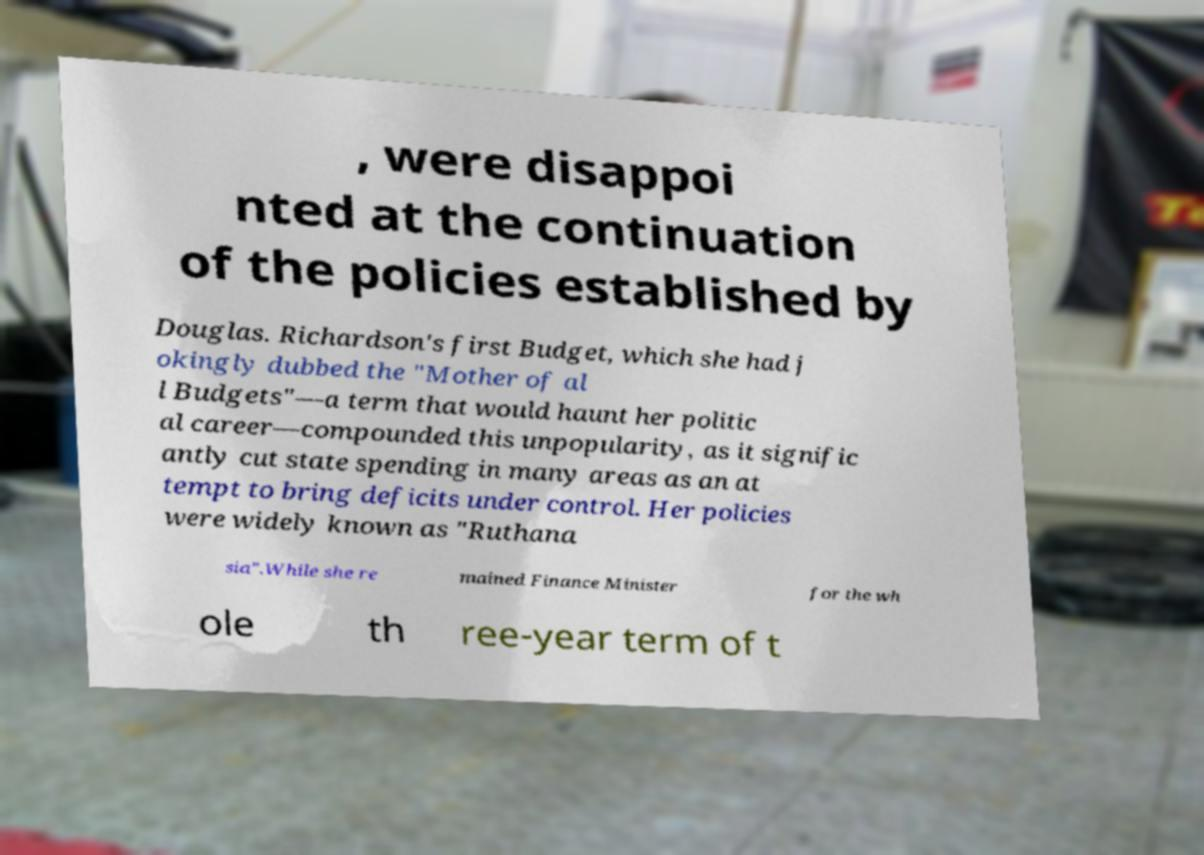For documentation purposes, I need the text within this image transcribed. Could you provide that? , were disappoi nted at the continuation of the policies established by Douglas. Richardson's first Budget, which she had j okingly dubbed the "Mother of al l Budgets"—a term that would haunt her politic al career—compounded this unpopularity, as it signific antly cut state spending in many areas as an at tempt to bring deficits under control. Her policies were widely known as "Ruthana sia".While she re mained Finance Minister for the wh ole th ree-year term of t 